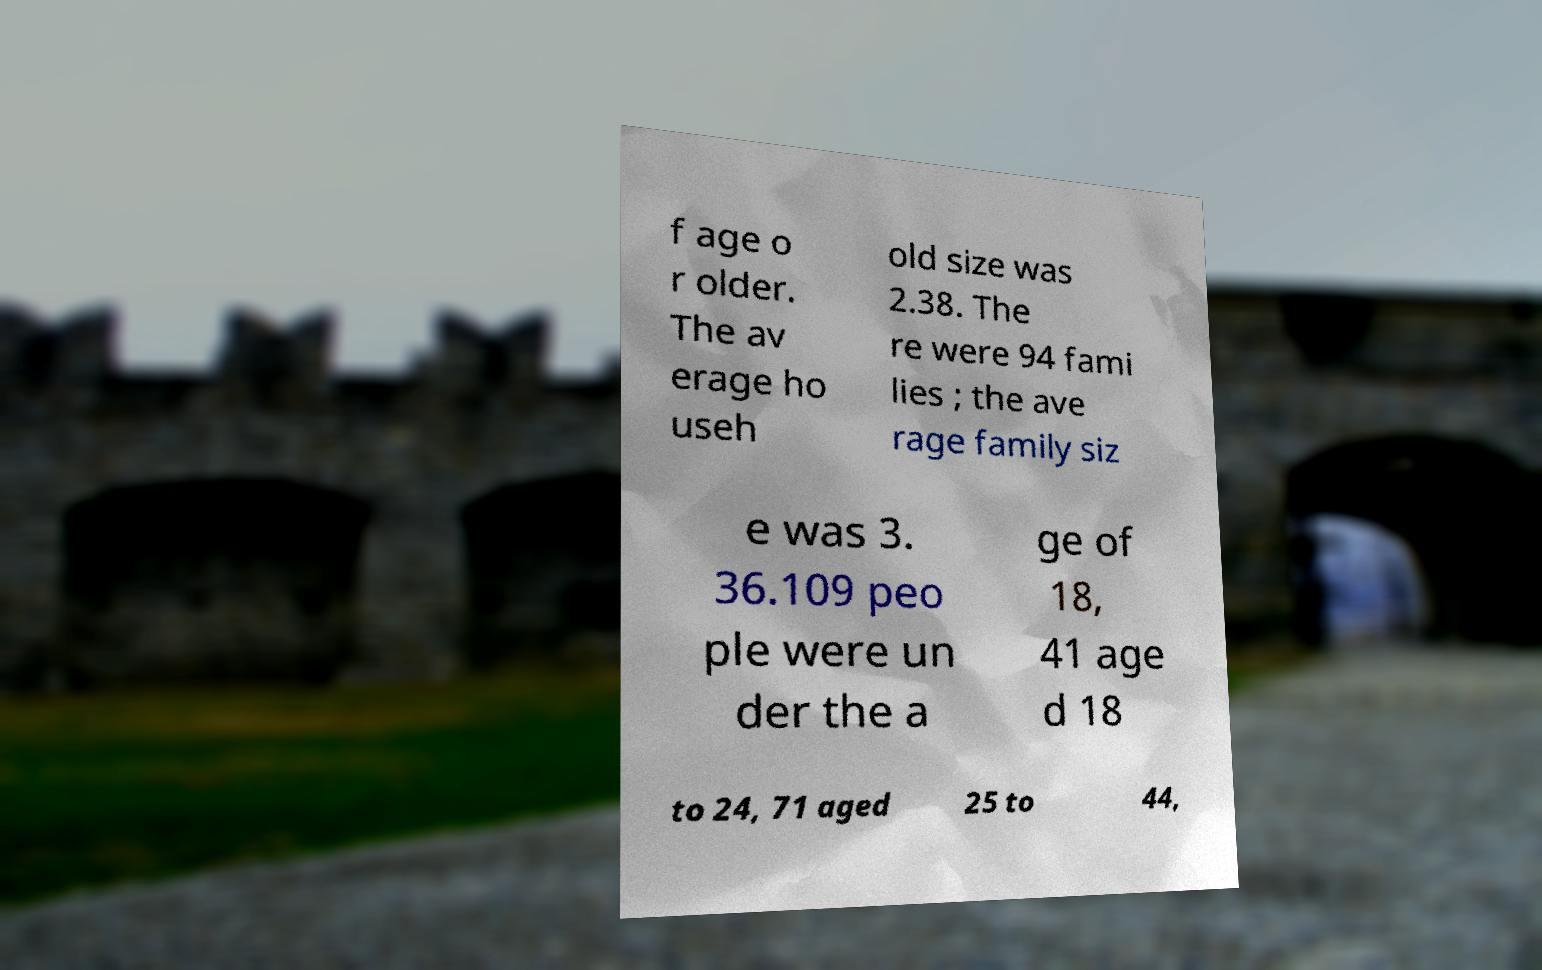Could you extract and type out the text from this image? f age o r older. The av erage ho useh old size was 2.38. The re were 94 fami lies ; the ave rage family siz e was 3. 36.109 peo ple were un der the a ge of 18, 41 age d 18 to 24, 71 aged 25 to 44, 